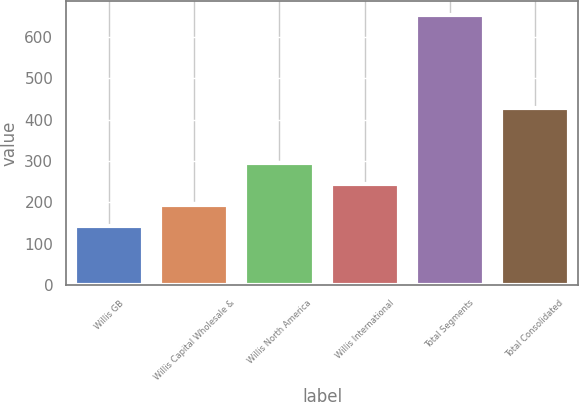Convert chart to OTSL. <chart><loc_0><loc_0><loc_500><loc_500><bar_chart><fcel>Willis GB<fcel>Willis Capital Wholesale &<fcel>Willis North America<fcel>Willis International<fcel>Total Segments<fcel>Total Consolidated<nl><fcel>143<fcel>194<fcel>296<fcel>245<fcel>653<fcel>427<nl></chart> 